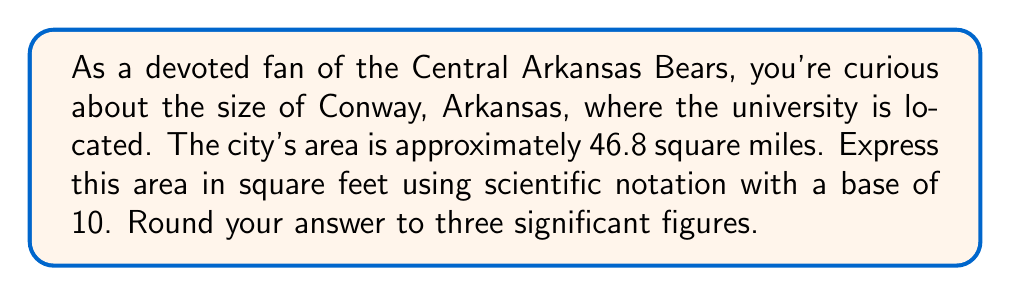Give your solution to this math problem. To solve this problem, we'll follow these steps:

1) First, convert square miles to square feet:
   1 square mile = 5280 ft × 5280 ft = 27,878,400 sq ft

2) Multiply the area in square miles by this conversion factor:
   $46.8 \text{ sq miles} \times 27,878,400 \text{ sq ft/sq mile} = 1,304,709,120 \text{ sq ft}$

3) Now, we need to express this in scientific notation with base 10:
   $1,304,709,120 = 1.304709120 \times 10^9$

4) Rounding to three significant figures:
   $1.30 \times 10^9 \text{ sq ft}$

Therefore, the area of Conway, Arkansas, expressed in square feet using scientific notation (base 10) and rounded to three significant figures is $1.30 \times 10^9 \text{ sq ft}$.
Answer: $1.30 \times 10^9 \text{ sq ft}$ 